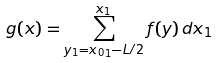Convert formula to latex. <formula><loc_0><loc_0><loc_500><loc_500>g ( x ) = \sum ^ { x _ { 1 } } _ { y _ { 1 } = { x _ { 0 } } _ { 1 } - L / 2 } f ( y ) \, d x _ { 1 }</formula> 